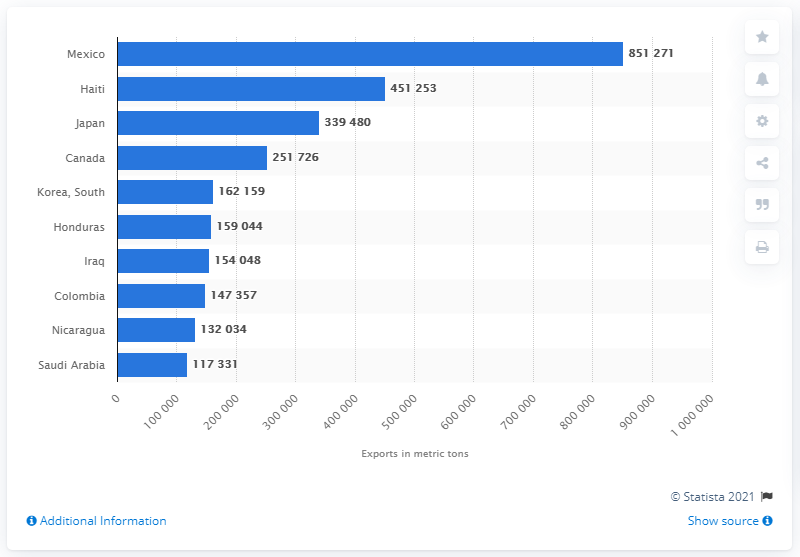Highlight a few significant elements in this photo. In 2019, Mexico was the top destination for U.S. rice exports, making it the most important country for rice exports from the United States. 